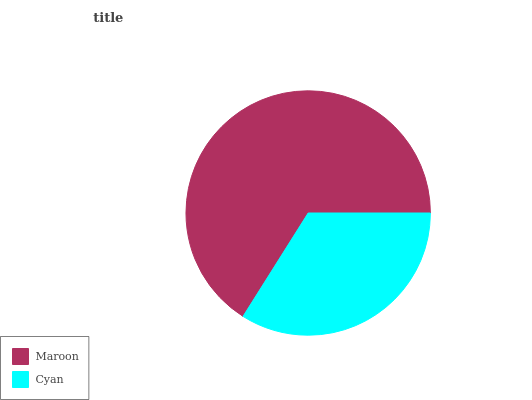Is Cyan the minimum?
Answer yes or no. Yes. Is Maroon the maximum?
Answer yes or no. Yes. Is Cyan the maximum?
Answer yes or no. No. Is Maroon greater than Cyan?
Answer yes or no. Yes. Is Cyan less than Maroon?
Answer yes or no. Yes. Is Cyan greater than Maroon?
Answer yes or no. No. Is Maroon less than Cyan?
Answer yes or no. No. Is Maroon the high median?
Answer yes or no. Yes. Is Cyan the low median?
Answer yes or no. Yes. Is Cyan the high median?
Answer yes or no. No. Is Maroon the low median?
Answer yes or no. No. 